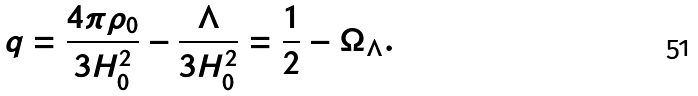Convert formula to latex. <formula><loc_0><loc_0><loc_500><loc_500>q = \frac { 4 \pi \rho _ { 0 } } { 3 H _ { 0 } ^ { 2 } } - \frac { \Lambda } { 3 H _ { 0 } ^ { 2 } } = \frac { 1 } { 2 } - \Omega _ { \Lambda } .</formula> 